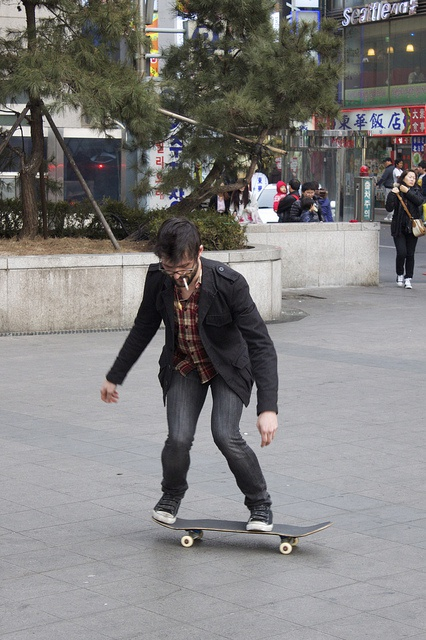Describe the objects in this image and their specific colors. I can see people in darkgray, black, gray, and maroon tones, people in darkgray, black, gray, and lightgray tones, skateboard in darkgray, gray, and black tones, people in darkgray, black, and gray tones, and people in darkgray, black, gray, and brown tones in this image. 